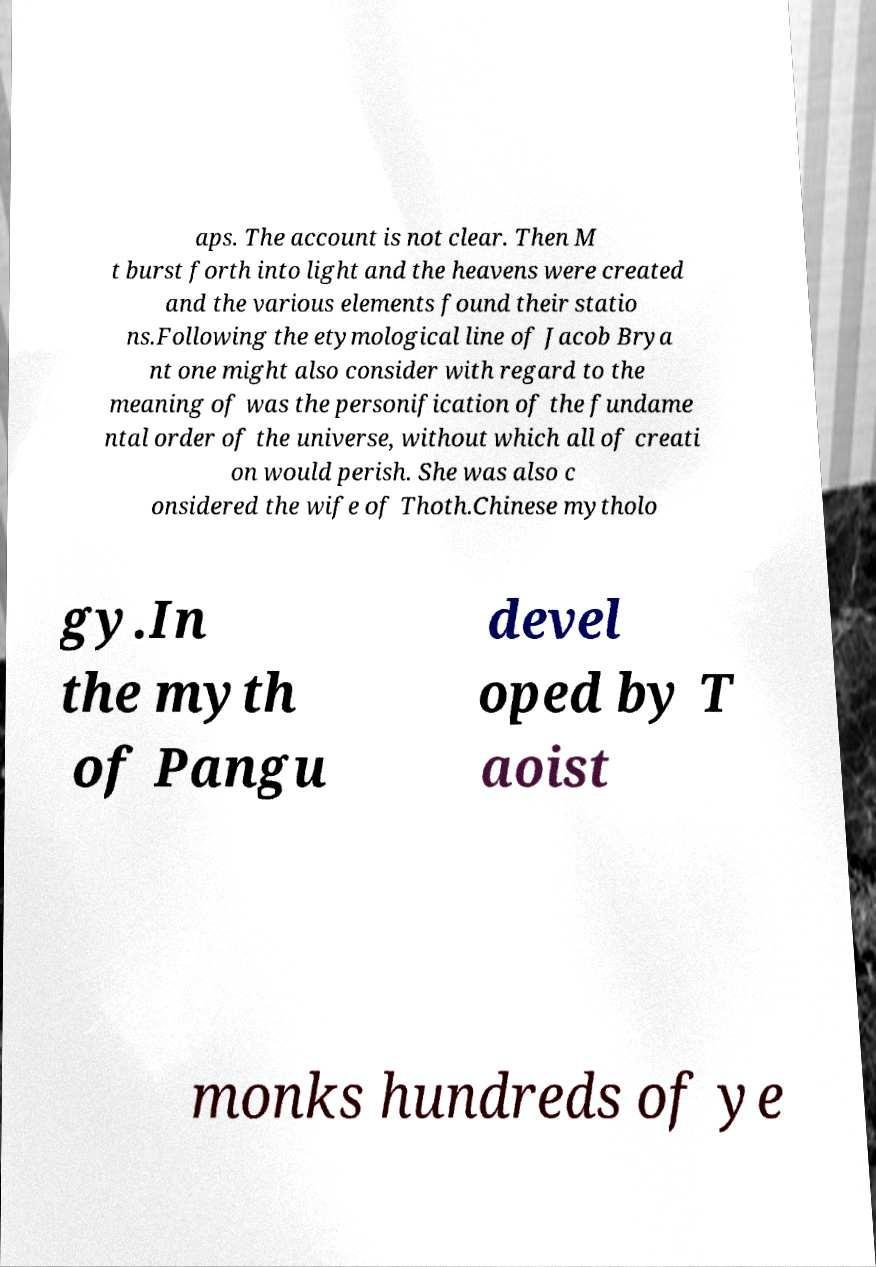Please identify and transcribe the text found in this image. aps. The account is not clear. Then M t burst forth into light and the heavens were created and the various elements found their statio ns.Following the etymological line of Jacob Brya nt one might also consider with regard to the meaning of was the personification of the fundame ntal order of the universe, without which all of creati on would perish. She was also c onsidered the wife of Thoth.Chinese mytholo gy.In the myth of Pangu devel oped by T aoist monks hundreds of ye 